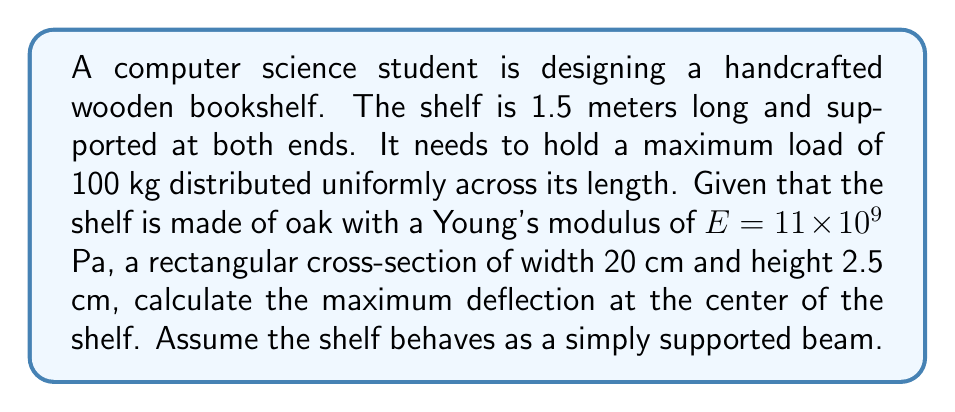What is the answer to this math problem? To solve this problem, we'll use the beam deflection formula for a uniformly distributed load:

1. The maximum deflection (y) for a simply supported beam with uniformly distributed load is given by:

   $$y = \frac{5wL^4}{384EI}$$

   Where:
   - w is the distributed load (N/m)
   - L is the length of the beam (m)
   - E is Young's modulus (Pa)
   - I is the moment of inertia (m^4)

2. Calculate the distributed load (w):
   Total load = 100 kg = 100 * 9.81 = 981 N
   $$w = \frac{981}{1.5} = 654 \text{ N/m}$$

3. Calculate the moment of inertia (I) for a rectangular cross-section:
   $$I = \frac{bh^3}{12} = \frac{0.2 \times 0.025^3}{12} = 2.604 \times 10^{-7} \text{ m}^4$$

4. Substitute the values into the deflection formula:
   $$y = \frac{5 \times 654 \times 1.5^4}{384 \times 11 \times 10^9 \times 2.604 \times 10^{-7}}$$

5. Simplify and calculate:
   $$y = \frac{5 \times 654 \times 5.0625}{384 \times 11 \times 10^9 \times 2.604 \times 10^{-7}} = 0.00395 \text{ m}$$

6. Convert to millimeters:
   $$y = 0.00395 \times 1000 = 3.95 \text{ mm}$$
Answer: 3.95 mm 